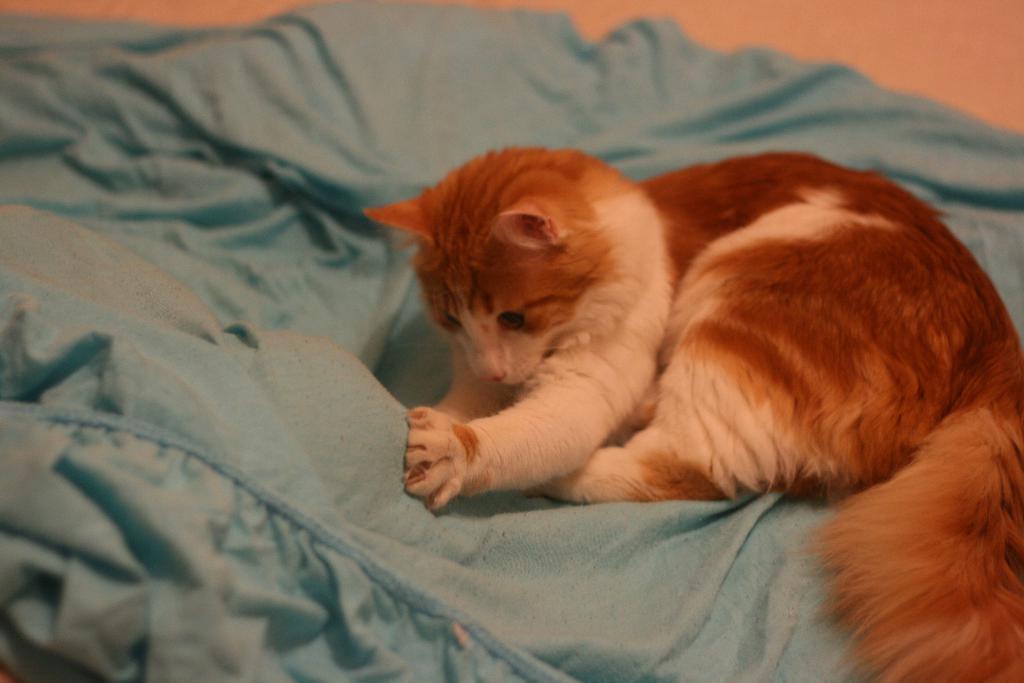Can you describe this image briefly? In this picture we can see brown and white cat is playing with a blue color bed sheet. 